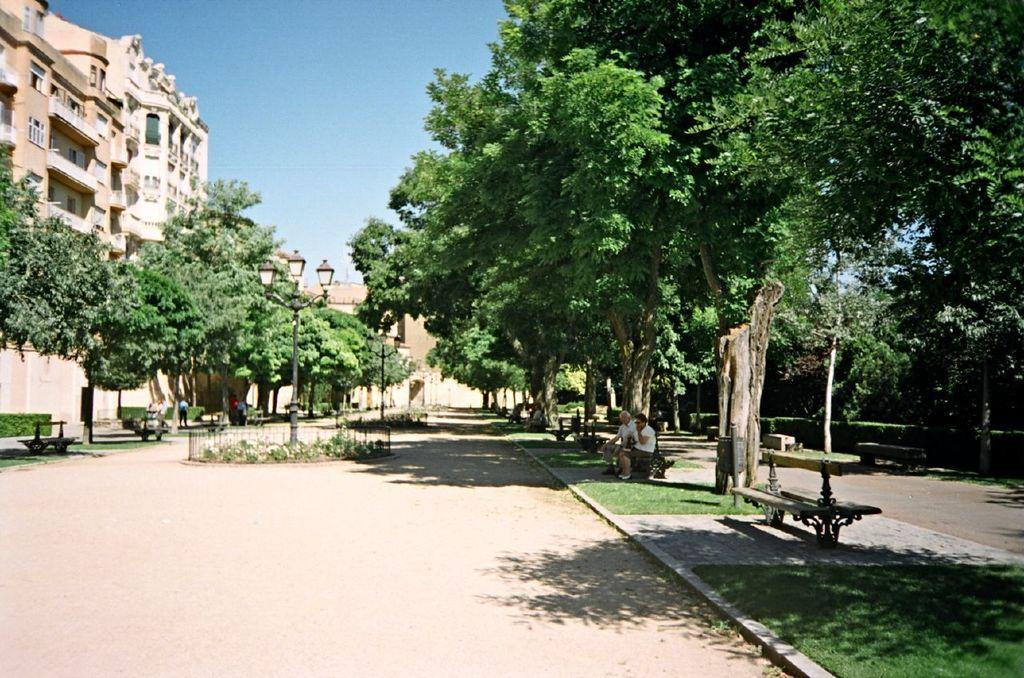Who or what can be seen in the image? There are people in the image. What type of natural elements are present in the image? There are trees and plants in the image. What type of seating is available in the image? There are benches in the image. What type of structures are present in the image? There are buildings in the image. What type of architectural features can be seen in the image? There are windows and light poles in the image. What part of the natural environment is visible in the image? The sky is visible in the image. What type of queen can be seen in the image? There is no queen present in the image. How many steps are visible in the image? There is no mention of steps in the provided facts, so it cannot be determined from the image. 